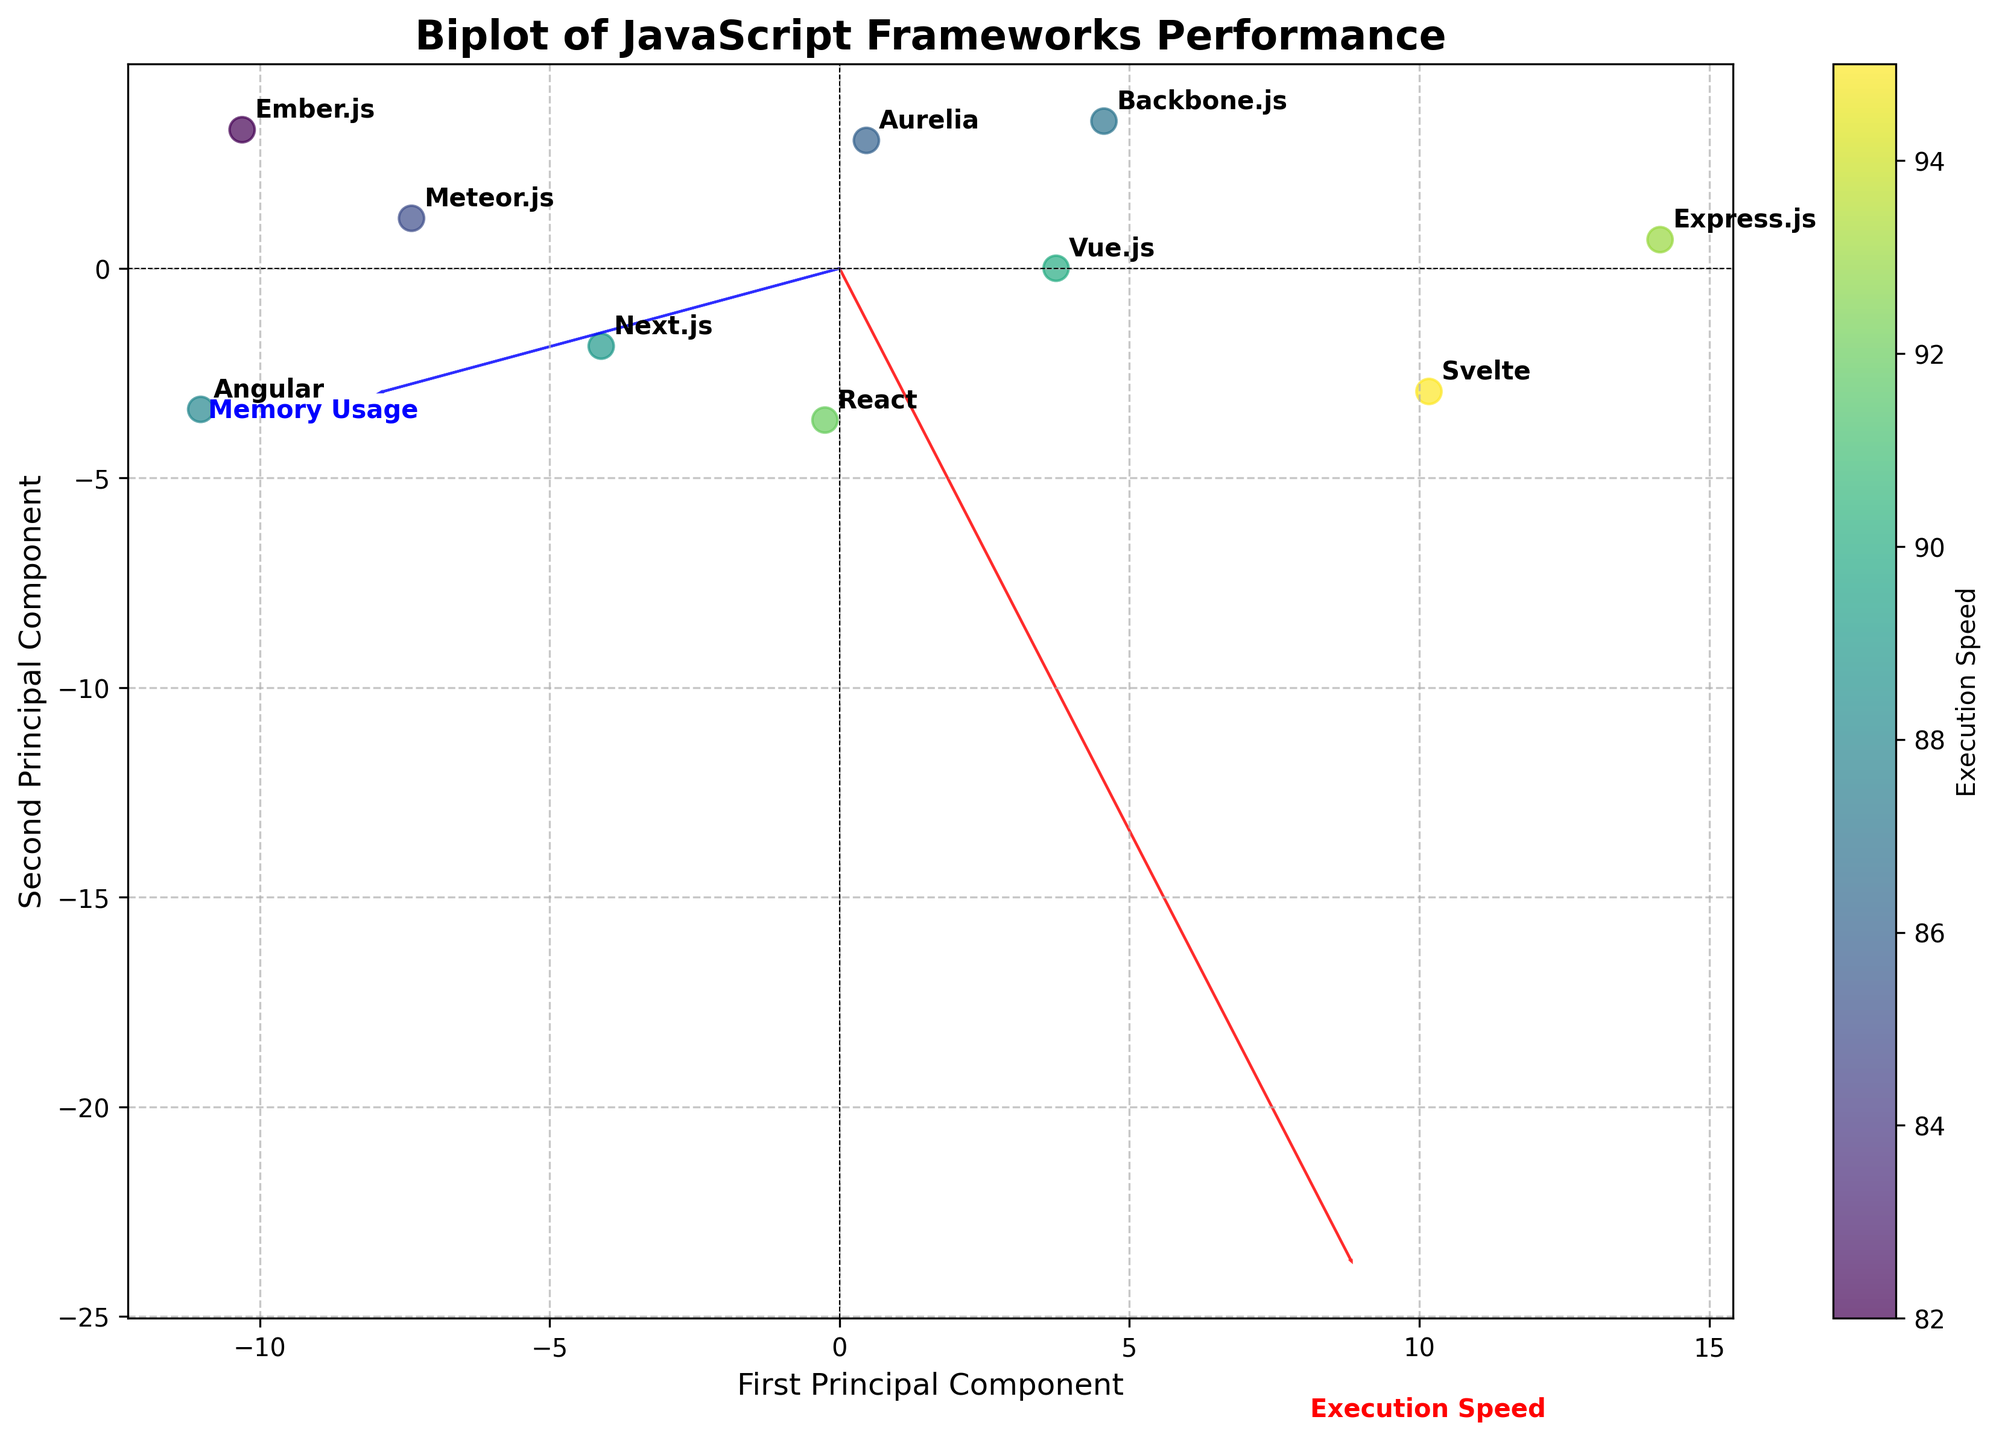what does the color of the data points represent? The color of the data points corresponds to the execution speed of the frameworks. The color bar on the right side of the plot indicates that higher execution speeds are indicated by colors closer to yellow, while lower execution speeds are closer to dark blue.
Answer: execution speed how many frameworks are analyzed in the biplot? By counting the data points and corresponding labels on the plot, we can determine the number of frameworks. Each data point represents one framework, and there are: Meteor.js, React, Angular, Vue.js, Svelte, Express.js, Next.js, Ember.js, Backbone.js, Aurelia.
Answer: 10 frameworks which framework has the highest execution speed? We observe the color bar and the annotated labels. The framework associated with the yellowest point will have the highest execution speed. From the plot, the Svelte point is the most yellow.
Answer: Svelte what are the two axes representing in the biplot? The x-axis is labeled as 'First Principal Component', and the y-axis is labeled as 'Second Principal Component'. These components are derived from the PCA and represent the directions in which the data varies the most.
Answer: first principal component and second principal component which framework uses the least memory? By looking at the points closer to the origin of the 'Memory Usage' feature vector (the arrow labeled 'Memory Usage'), we can compare the relative distances. Express.js is closest to this vector's origin, indicating it uses the least memory.
Answer: Express.js which framework has the highest memory usage? We observe the points farthest from the origin along the 'Memory Usage' feature vector (blue arrow). Ember.js is farthest, indicating it has the highest memory usage.
Answer: Ember.js what does the length of feature vectors represent? The lengths of the feature vectors (Execution Speed and Memory Usage) indicate the strength and influence of these features in the data. Longer vectors suggest more variance explained by that feature.
Answer: strength and influence of features which framework is located closest to the origin? The framework closest to the origin of the biplot is Aurelia, indicating it is closest to the mean values of both principal components.
Answer: Aurelia are there any frameworks with similar performance metrics? By observing clusters of points or points that are close together, we see that Angular and Aurelia are very close to each other, indicating they have similar performance metrics.
Answer: Angular and Aurelia 